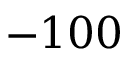Convert formula to latex. <formula><loc_0><loc_0><loc_500><loc_500>- 1 0 0</formula> 